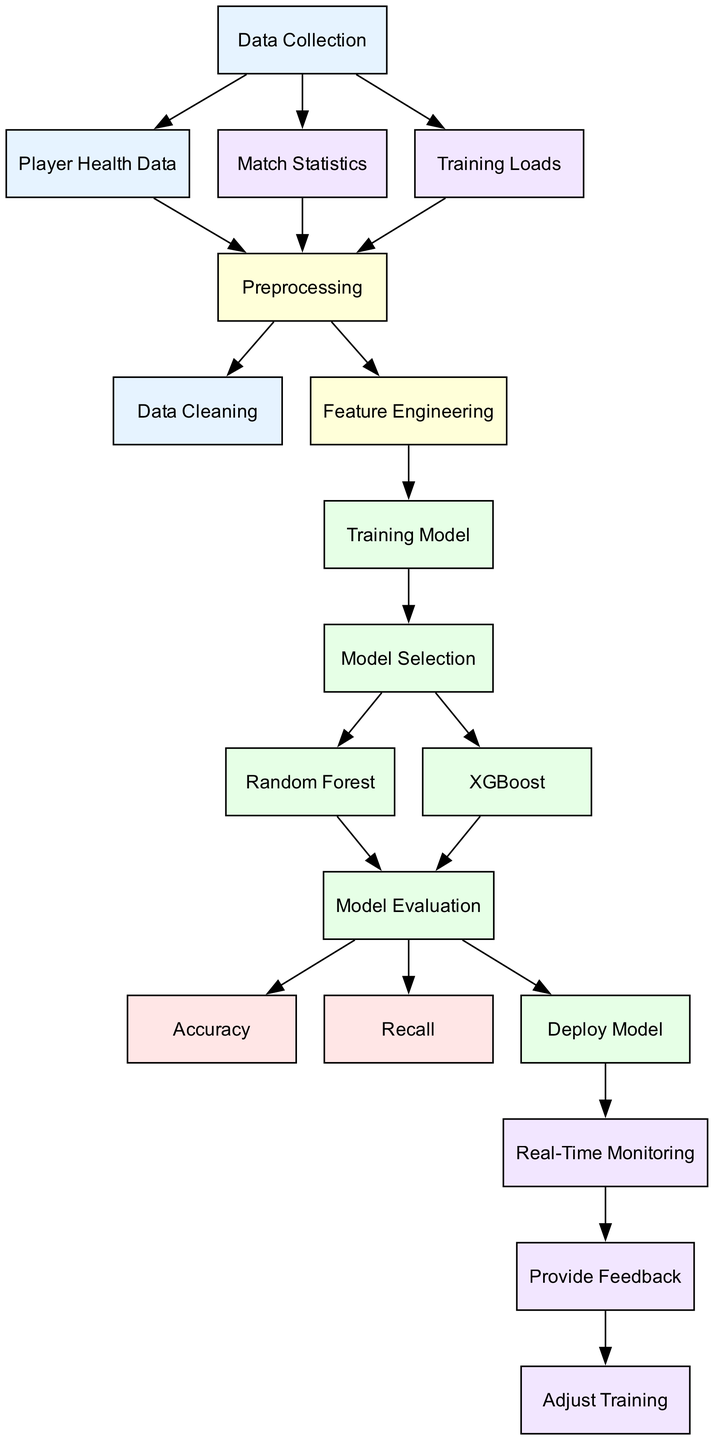What is the first step in the diagram? The diagram starts with the "Data Collection" node, which is the initial step before any processing happens.
Answer: Data Collection How many nodes are in the diagram? The diagram contains a total of 17 nodes, each representing different stages or components in the injury prediction and prevention process.
Answer: 17 What does the "Feature Engineering" node lead to? The "Feature Engineering" node directly leads to the "Training Model" node, indicating that after features are engineered, a model training process follows.
Answer: Training Model Which model is selected after the "Model Selection" node? After the "Model Selection" node, two models are presented: "Random Forest" and "XGBoost." It suggests that one or the other will be chosen for further evaluation.
Answer: Random Forest, XGBoost What is the last process depicted after "Real-Time Monitoring"? The last process shown in the diagram is the "Adjust Training" node, which is influenced by feedback obtained during real-time monitoring.
Answer: Adjust Training How are the player health data and match statistics connected in the flow? Player health data and match statistics both feed into the "Preprocessing" node, indicating that these datasets are handled together before further processing.
Answer: Preprocessing What metrics are evaluated in the "Model Evaluation" node? The "Model Evaluation" node assesses "Accuracy" and "Recall," which are important metrics used to determine the performance of the trained models.
Answer: Accuracy, Recall What follows after the "Deploy Model" stage? Following the "Deploy Model" stage, the "Real-Time Monitoring" process takes place, enabling the monitoring of the model's performance on live data.
Answer: Real-Time Monitoring How do feedback mechanisms contribute to training adjustments? The "Provide Feedback" node connects to "Adjust Training," showing that feedback from real-time monitoring influences how training regimens or strategies are adjusted.
Answer: Adjust Training 